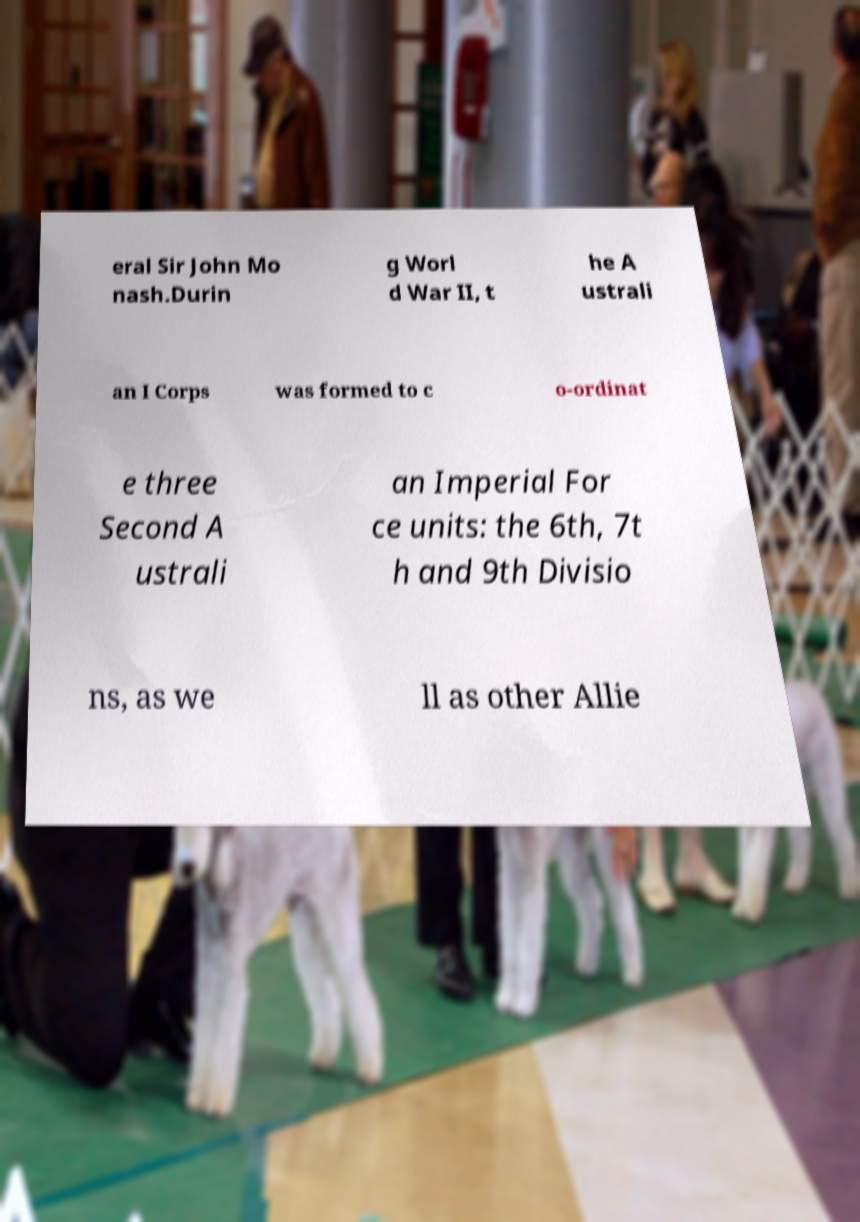Can you accurately transcribe the text from the provided image for me? eral Sir John Mo nash.Durin g Worl d War II, t he A ustrali an I Corps was formed to c o-ordinat e three Second A ustrali an Imperial For ce units: the 6th, 7t h and 9th Divisio ns, as we ll as other Allie 